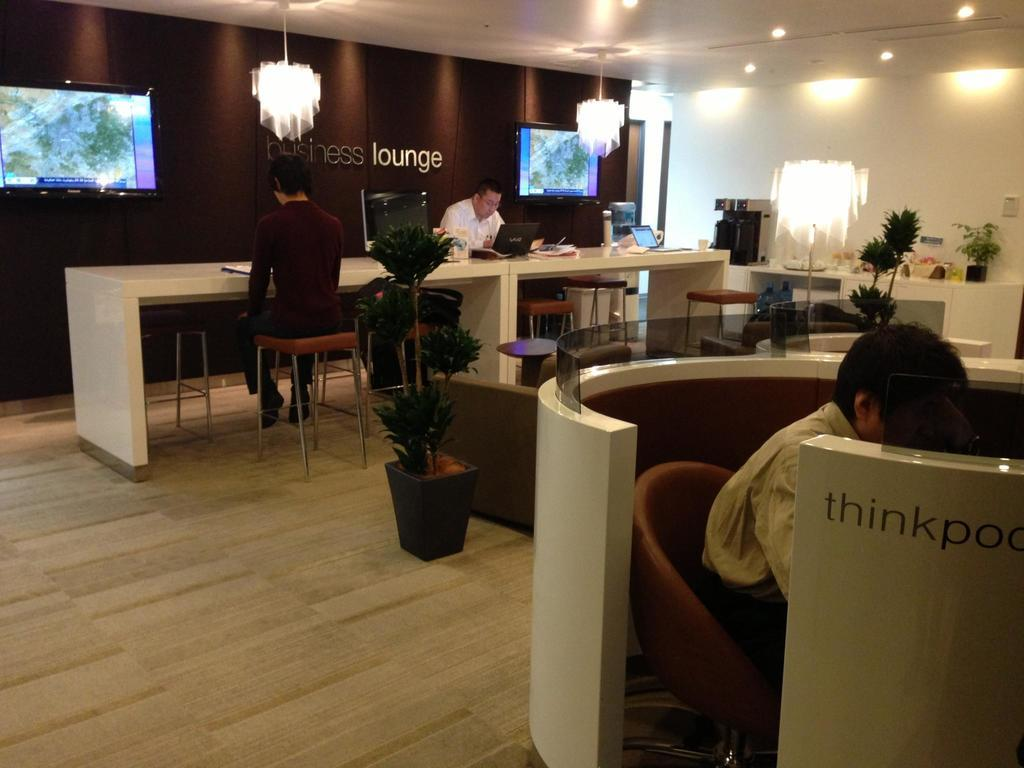How many people are in the image? There are three people in the image. What are the people doing in the image? The people are seated on chairs and working on laptops. What can be seen in the background of the image? There are plants and lights visible in the image. What is on the wall in the image? There are televisions on the wall in the image. What type of show is being cooked on the stove in the image? There is no stove or cooking activity present in the image. How many houses are visible in the image? There are no houses visible in the image. 